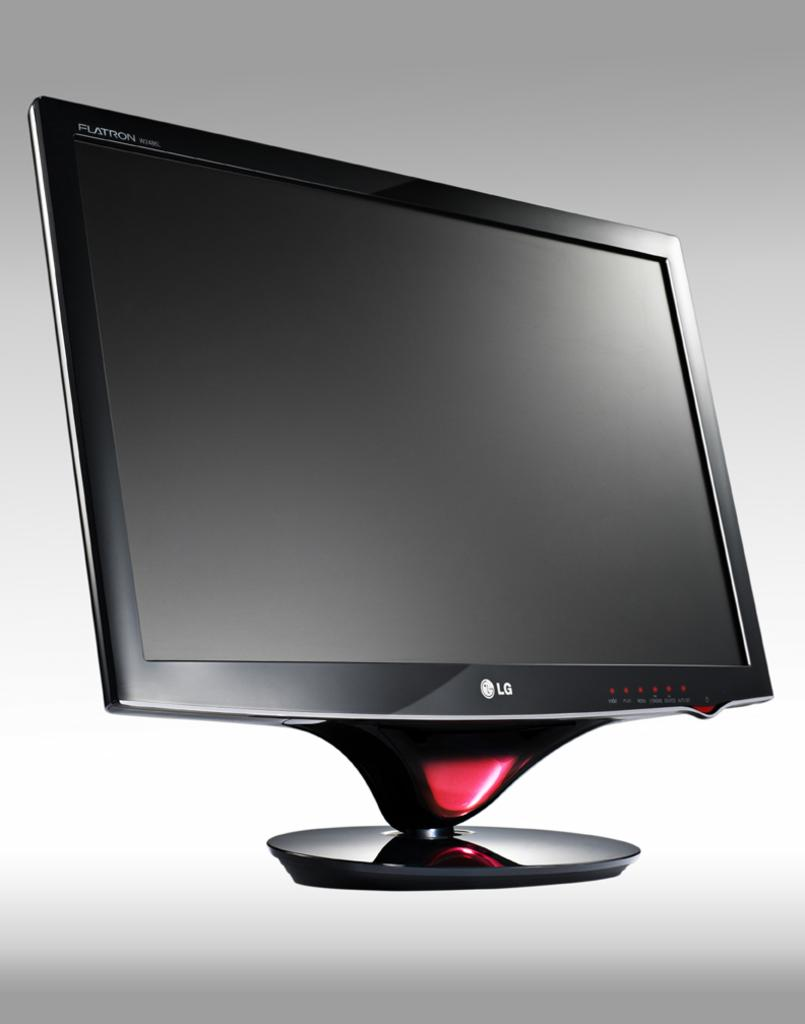Provide a one-sentence caption for the provided image. A black LG computer screen with red dots on the lower right hand corner. 